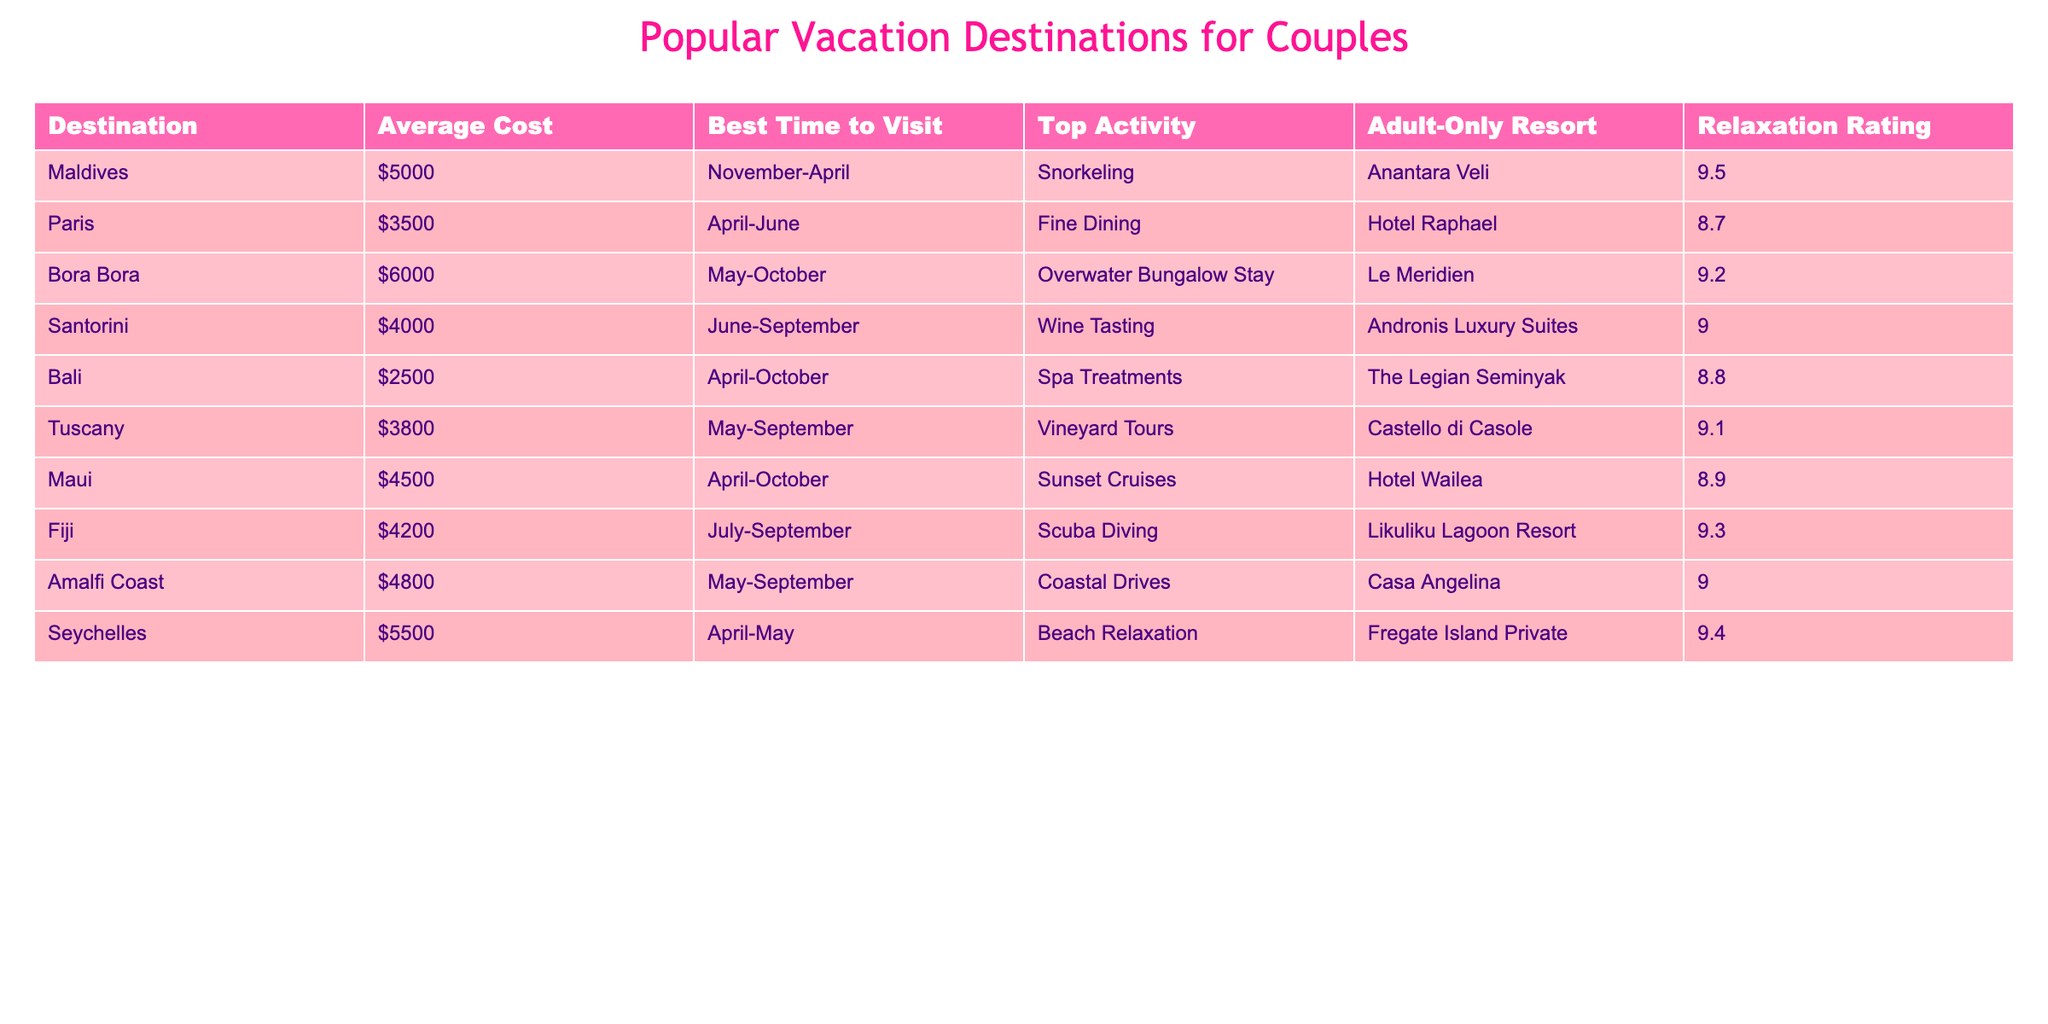What is the average cost of a vacation in Bali? The table shows that the average cost listed for Bali is $2500.
Answer: $2500 Which destination has the highest relaxation rating? Looking at the Relaxation Rating column, the Maldives has the highest score of 9.5.
Answer: Maldives Are all the destinations best visited during the months of April to October? By examining the Best Time to Visit column, only Bali and Maldives are entirely within these months, while others have overlapping months, but not exclusively.
Answer: No What is the total average cost of a vacation in Tuscany and Amalfi Coast? The average cost for Tuscany is $3800 and for Amalfi Coast is $4800. Adding these gives $3800 + $4800 = $8600.
Answer: $8600 Is there any destination with an Adult-Only Resort that has a relaxation rating above 9? By checking the Adult-Only Resort and Relaxation Rating columns, the Maldives, Bora Bora, Fiji, and Seychelles all qualify as they have resorts plus satisfaction ratings above 9.
Answer: Yes What is the average relaxation rating for destinations in the table? Adding the relaxation ratings: 9.5 + 8.7 + 9.2 + 9.0 + 8.8 + 9.1 + 8.9 + 9.3 + 9.4 = 80.9. There are 9 destinations, so the average is 80.9 / 9 = 8.99 (rounded).
Answer: 8.99 Which destination has the lowest average cost and what is that cost? The table indicates Bali has the lowest average cost at $2500.
Answer: $2500 During which months is the best time to visit Seychelles? The table indicates that the best time to visit Seychelles is April to May.
Answer: April-May How many destinations are ideal for relaxation with a rating of at least 9? By checking the Relaxation Rating column, the destinations with ratings of 9 or more are Maldives, Bora Bora, Fiji, Seychelles, and Tuscany, which equals 5 destinations.
Answer: 5 Which location is the second most expensive destination for couples? According to the Average Cost column, the second highest is the Seychelles with $5500.
Answer: Seychelles What activity is suggested in Santorini? The Top Activity column states that the suggested activity in Santorini is Wine Tasting.
Answer: Wine Tasting 